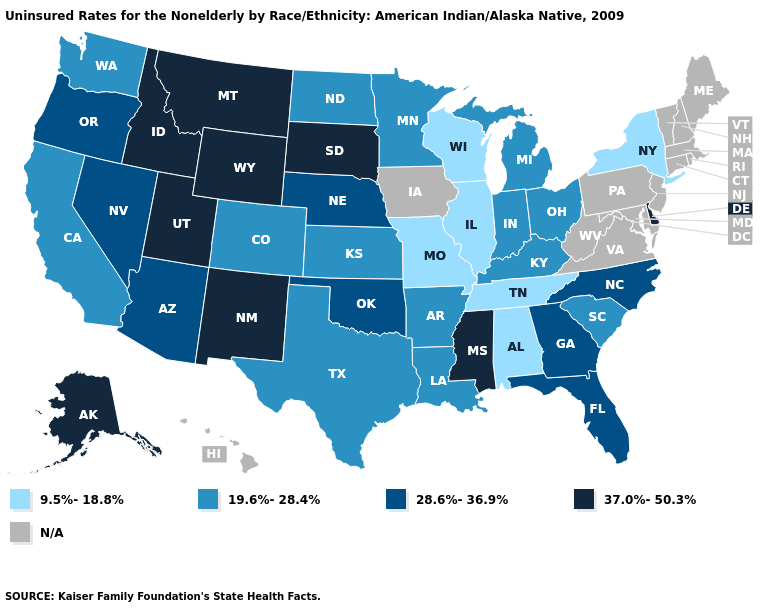Which states have the lowest value in the USA?
Give a very brief answer. Alabama, Illinois, Missouri, New York, Tennessee, Wisconsin. Does the first symbol in the legend represent the smallest category?
Give a very brief answer. Yes. What is the value of New Mexico?
Be succinct. 37.0%-50.3%. Name the states that have a value in the range 9.5%-18.8%?
Write a very short answer. Alabama, Illinois, Missouri, New York, Tennessee, Wisconsin. What is the value of Tennessee?
Quick response, please. 9.5%-18.8%. Among the states that border Mississippi , which have the lowest value?
Be succinct. Alabama, Tennessee. What is the value of Washington?
Concise answer only. 19.6%-28.4%. Name the states that have a value in the range N/A?
Be succinct. Connecticut, Hawaii, Iowa, Maine, Maryland, Massachusetts, New Hampshire, New Jersey, Pennsylvania, Rhode Island, Vermont, Virginia, West Virginia. What is the value of New Hampshire?
Be succinct. N/A. Does Mississippi have the highest value in the South?
Quick response, please. Yes. What is the highest value in states that border Kentucky?
Give a very brief answer. 19.6%-28.4%. Name the states that have a value in the range 9.5%-18.8%?
Answer briefly. Alabama, Illinois, Missouri, New York, Tennessee, Wisconsin. Among the states that border New Mexico , does Texas have the lowest value?
Answer briefly. Yes. What is the value of Oregon?
Concise answer only. 28.6%-36.9%. 